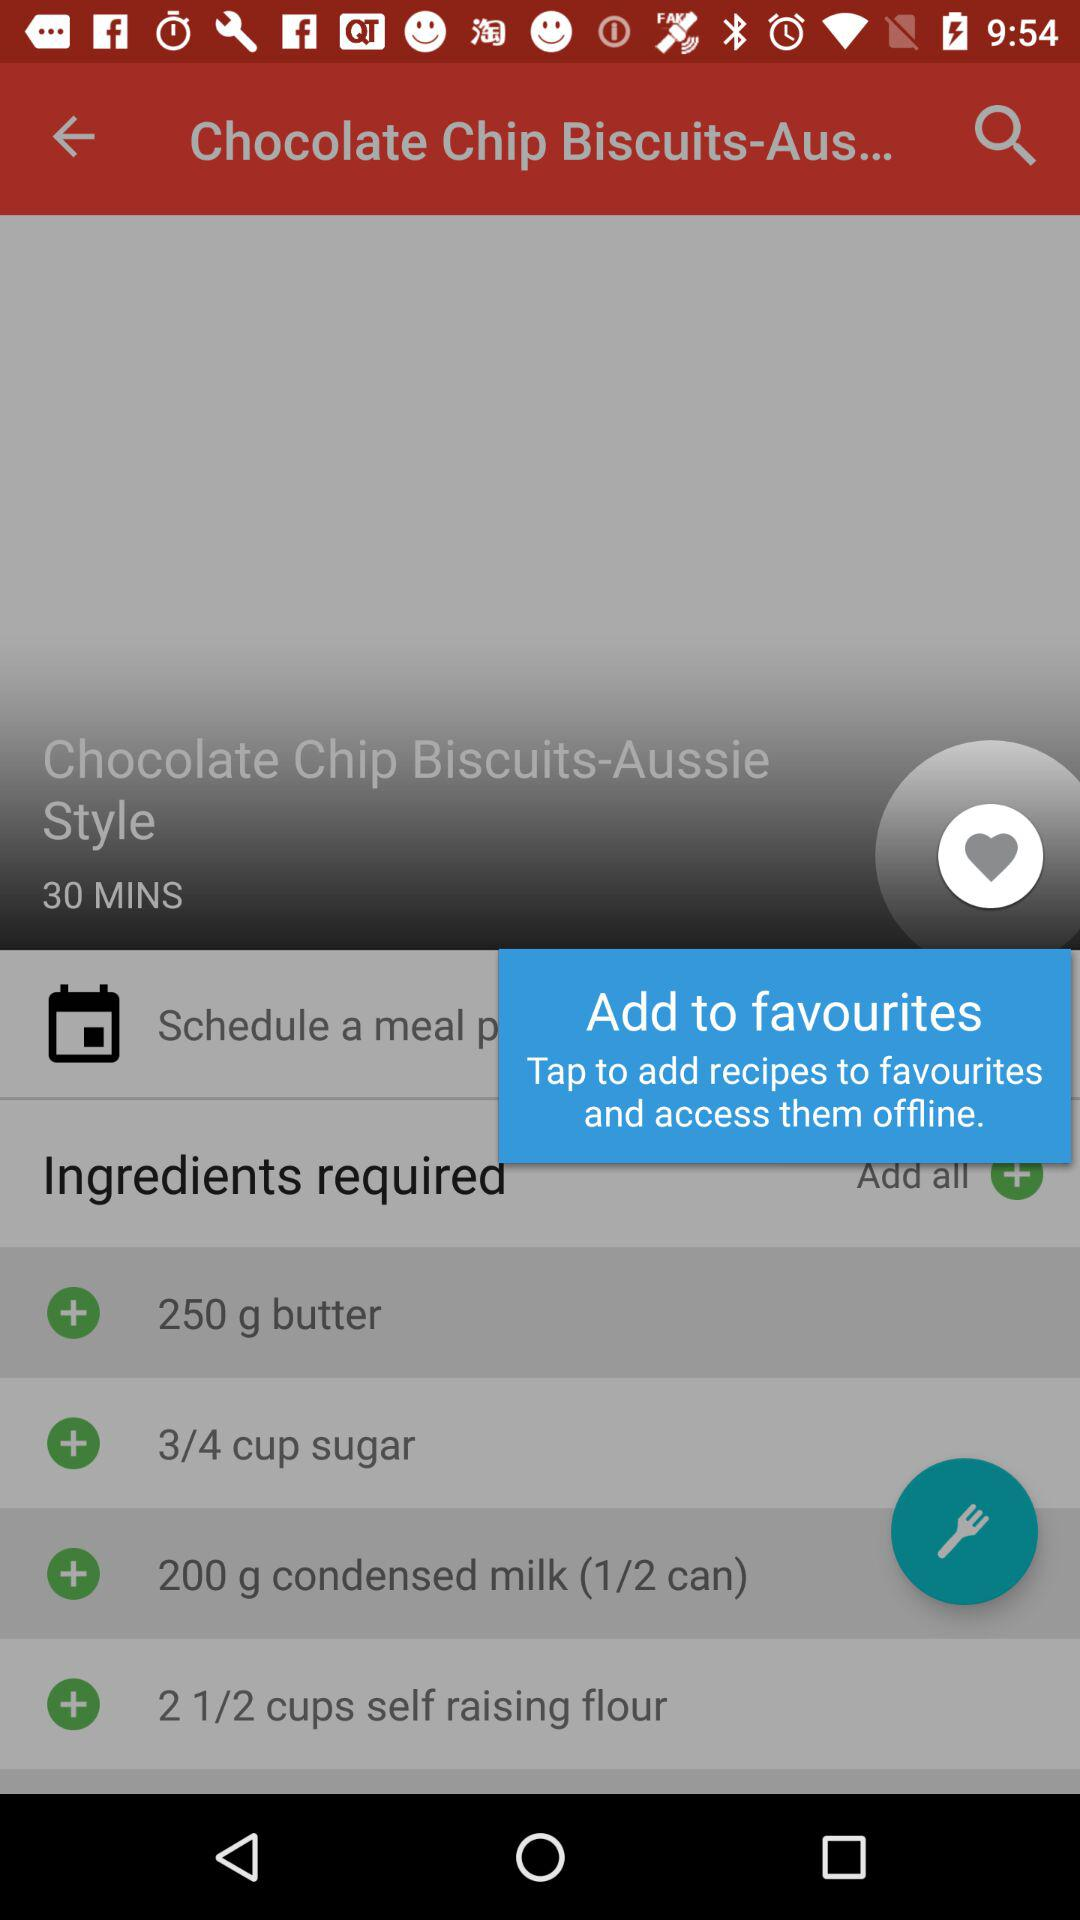How much condensed milk is required for the dish? The amount of condensed milk required for the dish is 200 g or (1/2 can). 